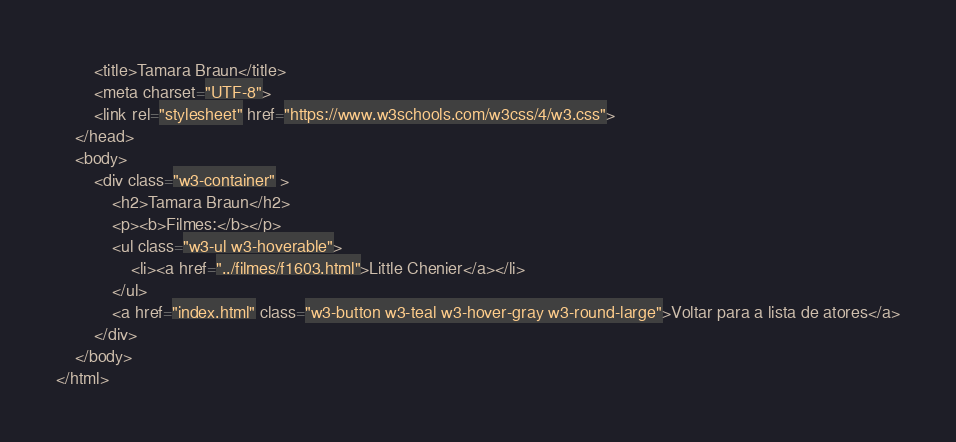Convert code to text. <code><loc_0><loc_0><loc_500><loc_500><_HTML_>        <title>Tamara Braun</title>
        <meta charset="UTF-8">
        <link rel="stylesheet" href="https://www.w3schools.com/w3css/4/w3.css">
    </head>
    <body>
        <div class="w3-container" >
            <h2>Tamara Braun</h2>
            <p><b>Filmes:</b></p>
            <ul class="w3-ul w3-hoverable">
				<li><a href="../filmes/f1603.html">Little Chenier</a></li>
			</ul>
            <a href="index.html" class="w3-button w3-teal w3-hover-gray w3-round-large">Voltar para a lista de atores</a>
        </div>
    </body>
</html></code> 